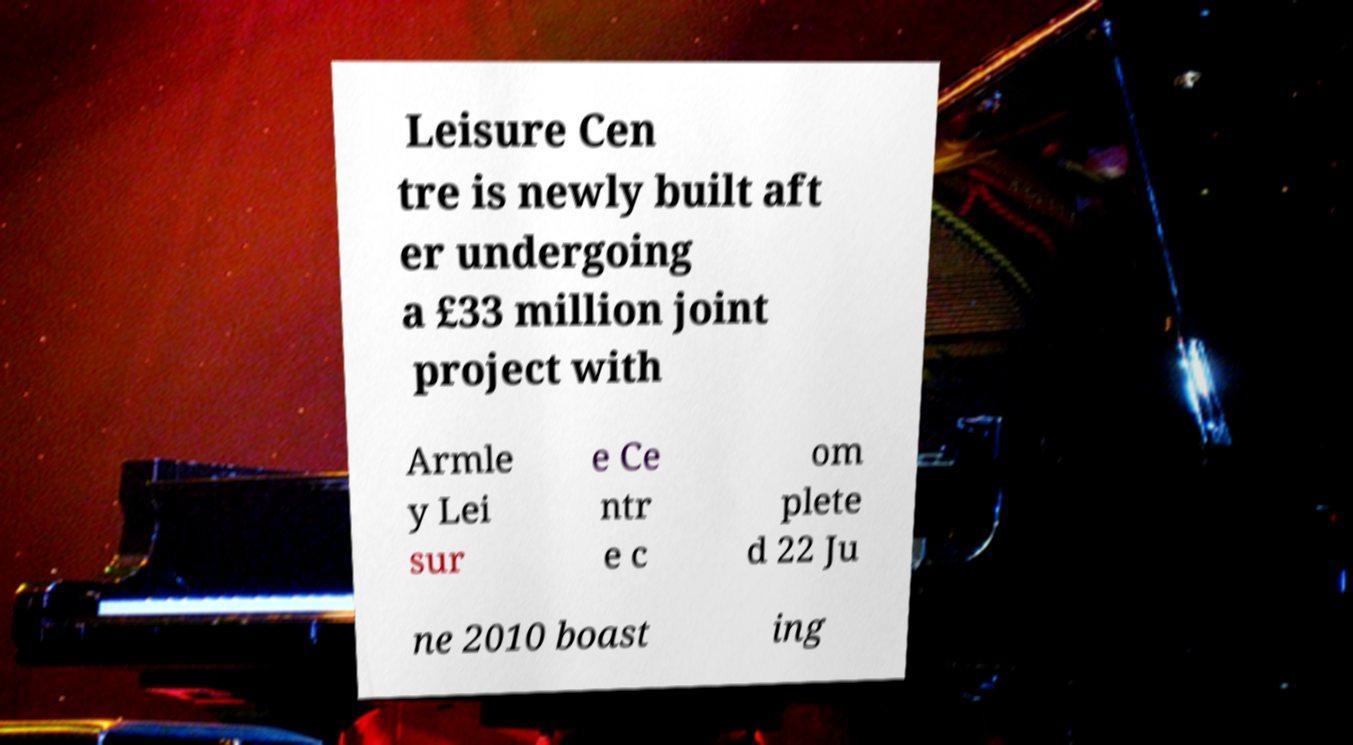Please identify and transcribe the text found in this image. Leisure Cen tre is newly built aft er undergoing a £33 million joint project with Armle y Lei sur e Ce ntr e c om plete d 22 Ju ne 2010 boast ing 